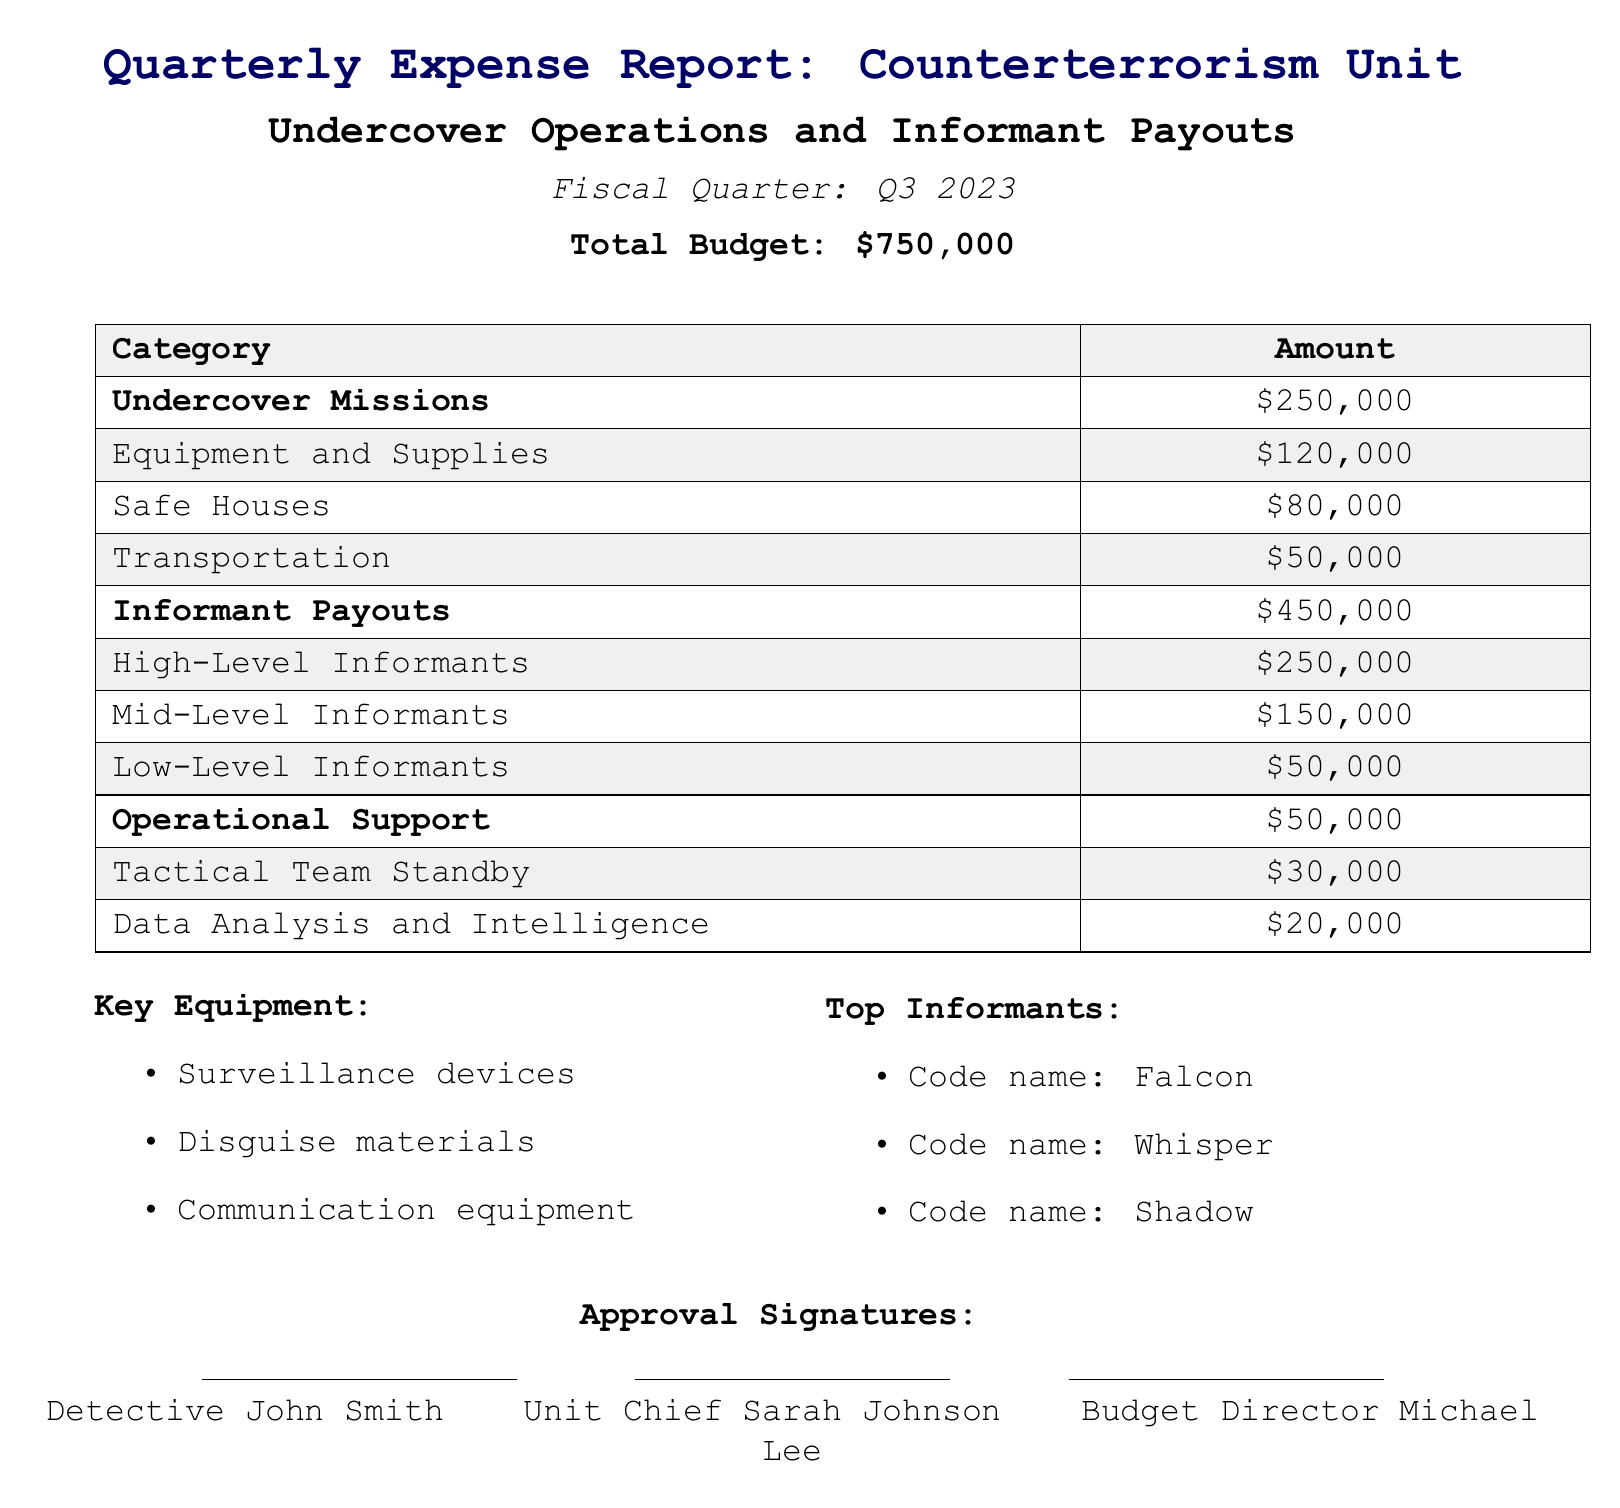What is the total budget for Q3 2023? The total budget is specified at the beginning of the document, which is \$750,000.
Answer: \$750,000 How much is allocated for undercover missions? The allocation for undercover missions is listed under the corresponding category in the table.
Answer: \$250,000 What is the amount set aside for high-level informants? The amount for high-level informants is included in the informant payouts section.
Answer: \$250,000 What types of key equipment are mentioned? The key equipment is listed in a bullet point format in the document.
Answer: Surveillance devices, Disguise materials, Communication equipment Which unit chief signed the report? The unit chief's name is stated in the approval signatures section of the document.
Answer: Sarah Johnson How much is allocated for safe houses? The expenditure for safe houses is clearly stated in the budget breakdown table.
Answer: \$80,000 What is the total amount for informant payouts? The total informant payouts can be found in the informative table that summarizes the costs.
Answer: \$450,000 What is the expenditure for tactical team standby? The expenditure for tactical team standby is shown in the operational support category.
Answer: \$30,000 Which code name is associated with a mid-level informant? The top informants include their respective code names, and one is a mid-level informant.
Answer: Whisper 